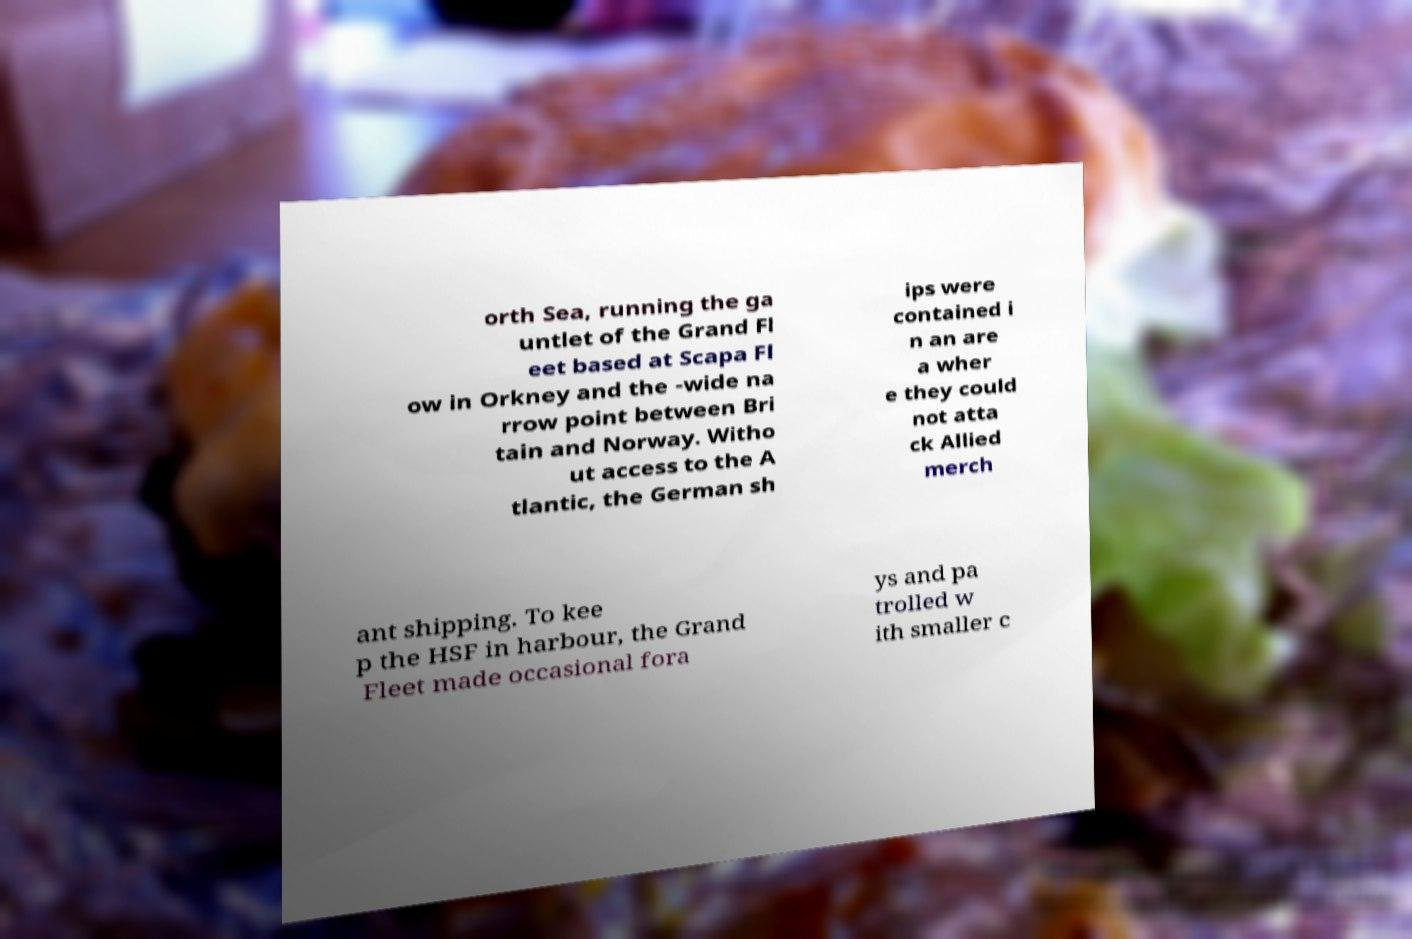Can you accurately transcribe the text from the provided image for me? orth Sea, running the ga untlet of the Grand Fl eet based at Scapa Fl ow in Orkney and the -wide na rrow point between Bri tain and Norway. Witho ut access to the A tlantic, the German sh ips were contained i n an are a wher e they could not atta ck Allied merch ant shipping. To kee p the HSF in harbour, the Grand Fleet made occasional fora ys and pa trolled w ith smaller c 